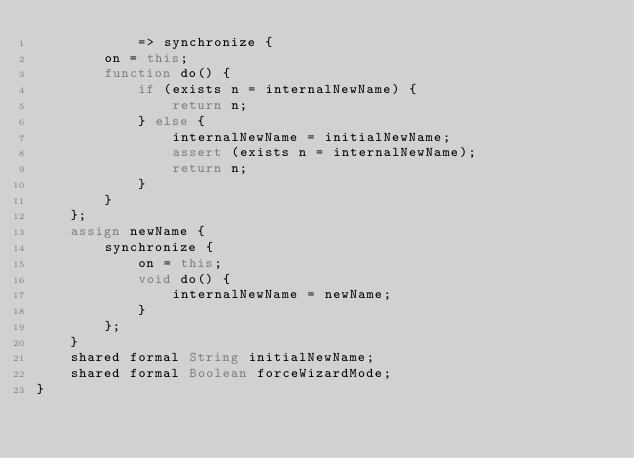Convert code to text. <code><loc_0><loc_0><loc_500><loc_500><_Ceylon_>            => synchronize {
        on = this;
        function do() {
            if (exists n = internalNewName) {
                return n;
            } else {
                internalNewName = initialNewName;
                assert (exists n = internalNewName);
                return n;
            }
        }
    };
    assign newName {
        synchronize {
            on = this;
            void do() {
                internalNewName = newName;
            }
        };
    }
    shared formal String initialNewName;
    shared formal Boolean forceWizardMode;
}

</code> 